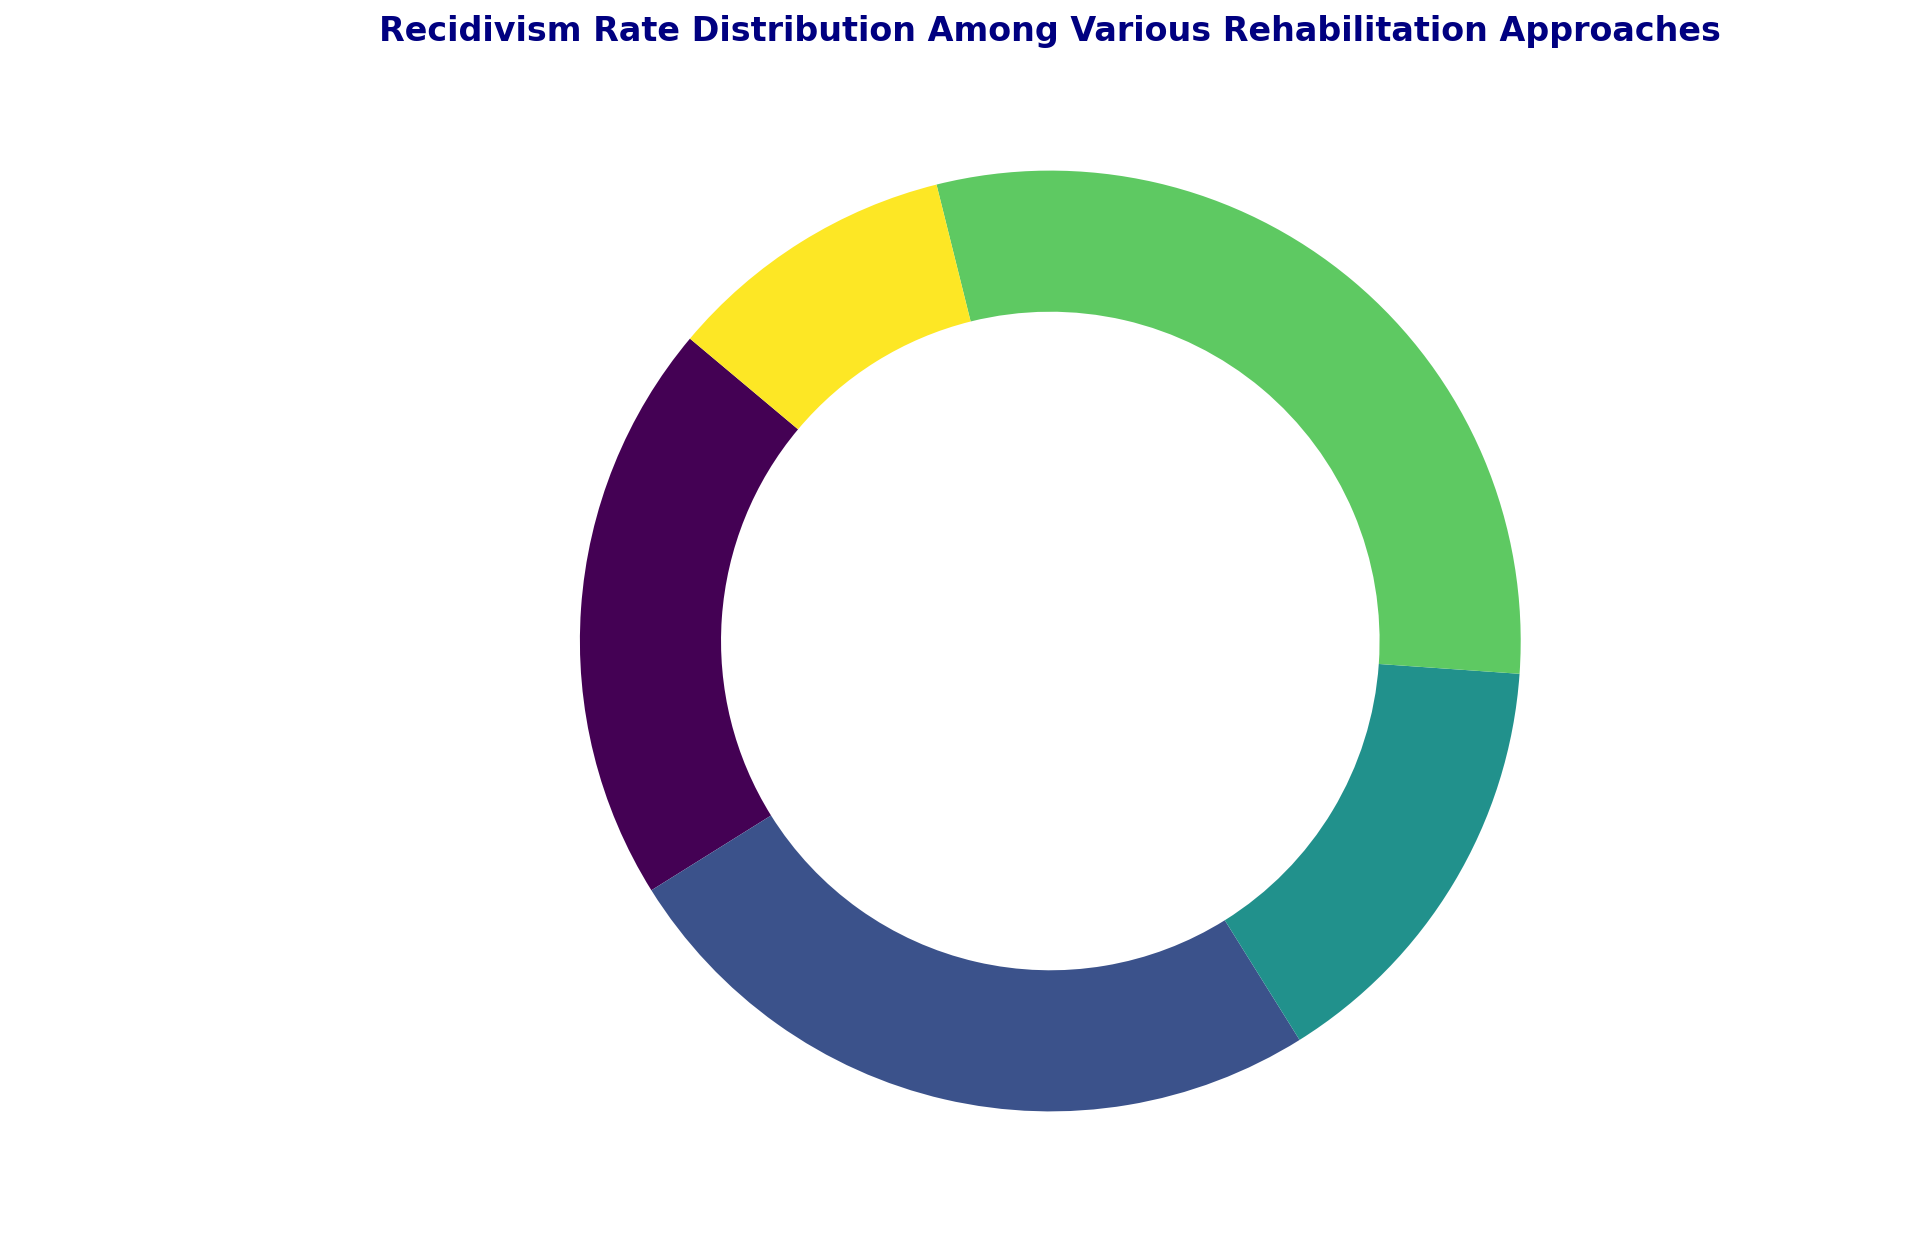What is the recidivism rate for Mental Health Treatment? The pie chart shows different rehabilitation approaches and their recidivism rates. For Mental Health Treatment, the section shows 15%.
Answer: 15% Which rehabilitation approach has the lowest recidivism rate? The pie chart segments should be checked to find the lowest percentage. Community-Based Programs show the lowest recidivism rate at 10%.
Answer: Community-Based Programs What is the combined recidivism rate for In-Prison Educational Programs and Vocational Training? The recidivism rates for In-Prison Educational Programs and Vocational Training are 20% and 25%, respectively. Adding them together gives 20% + 25% = 45%.
Answer: 45% Which rehabilitation approach has a higher recidivism rate: Vocational Training or Substance Abuse Programs? The pie chart shows Vocational Training at 25% and Substance Abuse Programs at 30%. Since 30% is greater than 25%, Substance Abuse Programs has a higher recidivism rate.
Answer: Substance Abuse Programs What is the difference in recidivism rates between the highest and lowest rate approaches? The maximum recidivism rate is for Substance Abuse Programs at 30% and the minimum is for Community-Based Programs at 10%. The difference is 30% - 10% = 20%.
Answer: 20% Which two rehabilitation approaches together account for half of the recidivism rates in the chart? Checking the pie chart for combinations, In-Prison Educational Programs (20%) and Substance Abuse Programs (30%) together make 20% + 30% = 50%, which is half of the total.
Answer: In-Prison Educational Programs and Substance Abuse Programs How many approaches have a recidivism rate below 25%? The pie chart shows recidivism rates of 20%, 15%, and 10% for three approaches: In-Prison Educational Programs, Mental Health Treatment, and Community-Based Programs. These three rates are all below 25%.
Answer: 3 